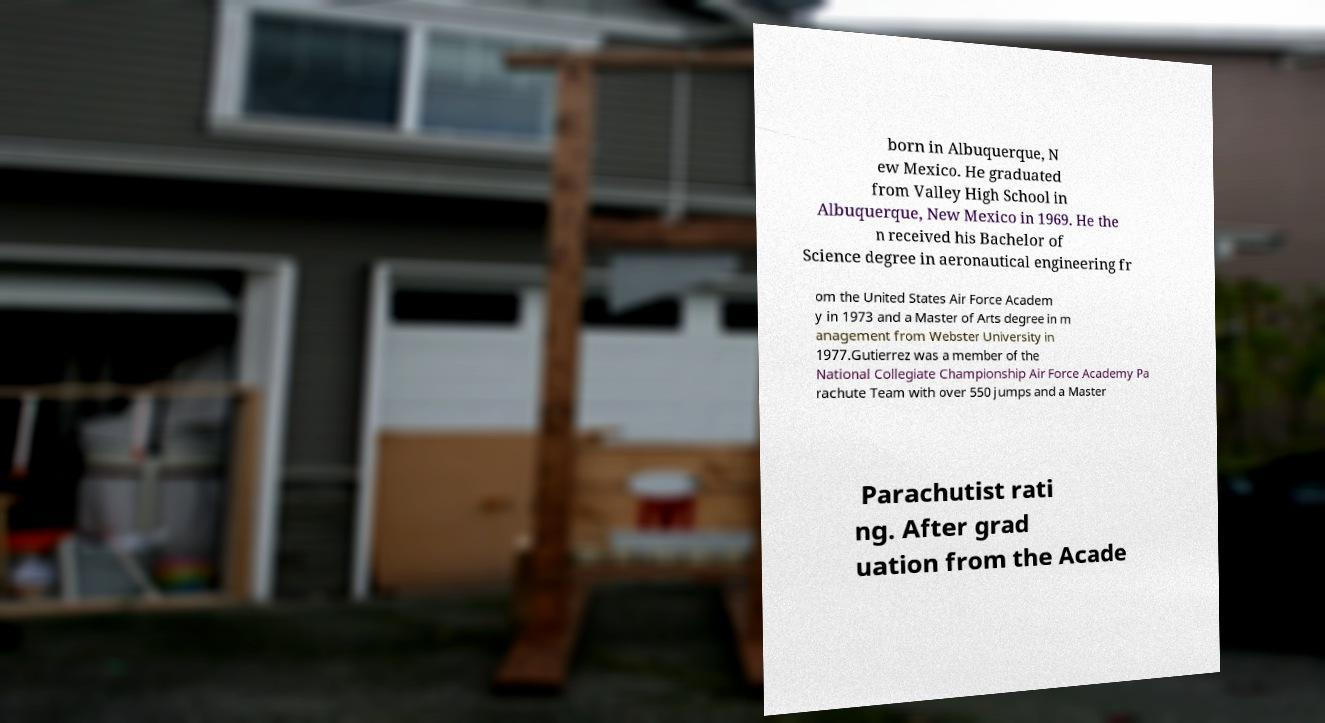There's text embedded in this image that I need extracted. Can you transcribe it verbatim? born in Albuquerque, N ew Mexico. He graduated from Valley High School in Albuquerque, New Mexico in 1969. He the n received his Bachelor of Science degree in aeronautical engineering fr om the United States Air Force Academ y in 1973 and a Master of Arts degree in m anagement from Webster University in 1977.Gutierrez was a member of the National Collegiate Championship Air Force Academy Pa rachute Team with over 550 jumps and a Master Parachutist rati ng. After grad uation from the Acade 